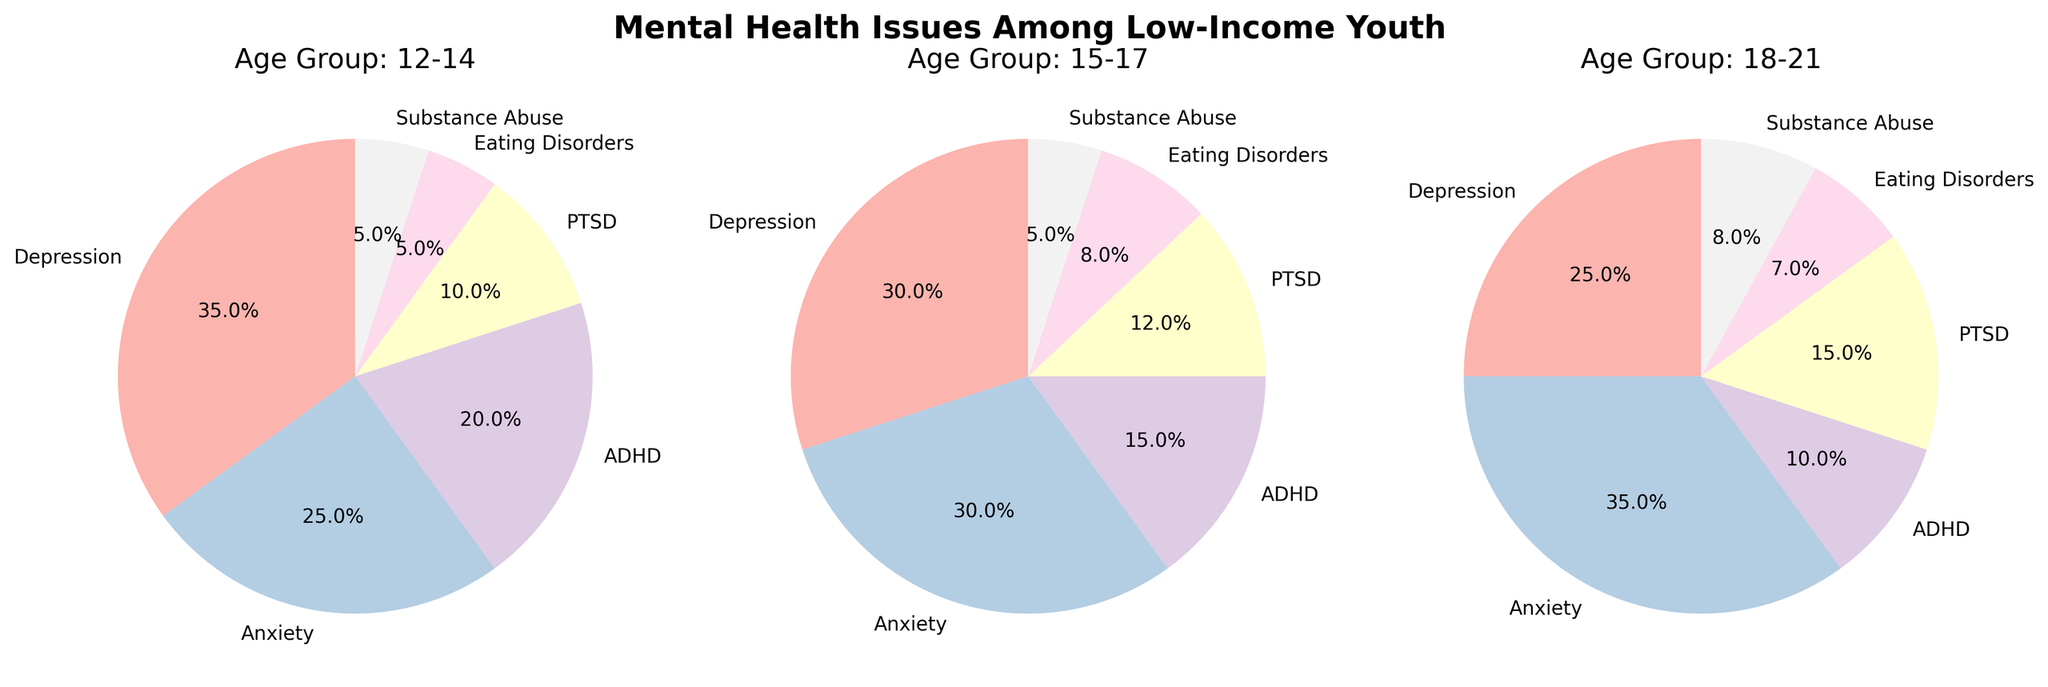What is the title of the figure? The title is usually displayed at the top of the figure. In this case, the title is "Mental Health Issues Among Low-Income Youth" as stated.
Answer: Mental Health Issues Among Low-Income Youth In the 12-14 age group, which mental health issue has the highest percentage? Looking at the pie chart for the 12-14 age group, the slice with the label showing the highest percentage is for Depression.
Answer: Depression Which age group has the highest percentage of anxiety? By comparing the percentage slices for Anxiety across all three age groups, you see that the 18-21 age group has the largest slice and the highest percentage for Anxiety.
Answer: 18-21 In the 15-17 age group, what is the combined percentage for ADHD and PTSD? Looking at the pie chart for the 15-17 age group, the percentage for ADHD is 15.0% and for PTSD is 12.0%. Adding these percentages gives 15.0% + 12.0% = 27.0%.
Answer: 27.0% Which mental health issue has the lowest representation in the 18-21 age group? The smallest slice in the pie chart for the 18-21 age group is for ADHD.
Answer: ADHD How does the percentage of substance abuse compare between the 12-14 and 18-21 age groups? For Substance Abuse in the 12-14 age group, the percentage is 5.0%. In the 18-21 age group, it is 8.0%. Comparing these, 8.0% is greater than 5.0%.
Answer: Substance Abuse is higher in the 18-21 age group What is the total percentage for Eating Disorders across all age groups? Add the Eating Disorders percentages from all groups: 5.0% (12-14) + 8.0% (15-17) + 7.0% (18-21) = 20.0%.
Answer: 20.0% For which age group is PTSD more prevalent, and by how much, when comparing the 12-14 and 15-17 age groups? Referring to the pie charts, PTSD is 12.0% for 15-17 and 10.0% for 12-14. The difference is 12.0% - 10.0% = 2.0%.
Answer: 15-17 by 2.0% Among the three age groups, which one has the least variation in the distribution of mental health issues? Observing the uniformity of slices, the 12-14 age group appears more evenly distributed across categories, indicating less variation.
Answer: 12-14 